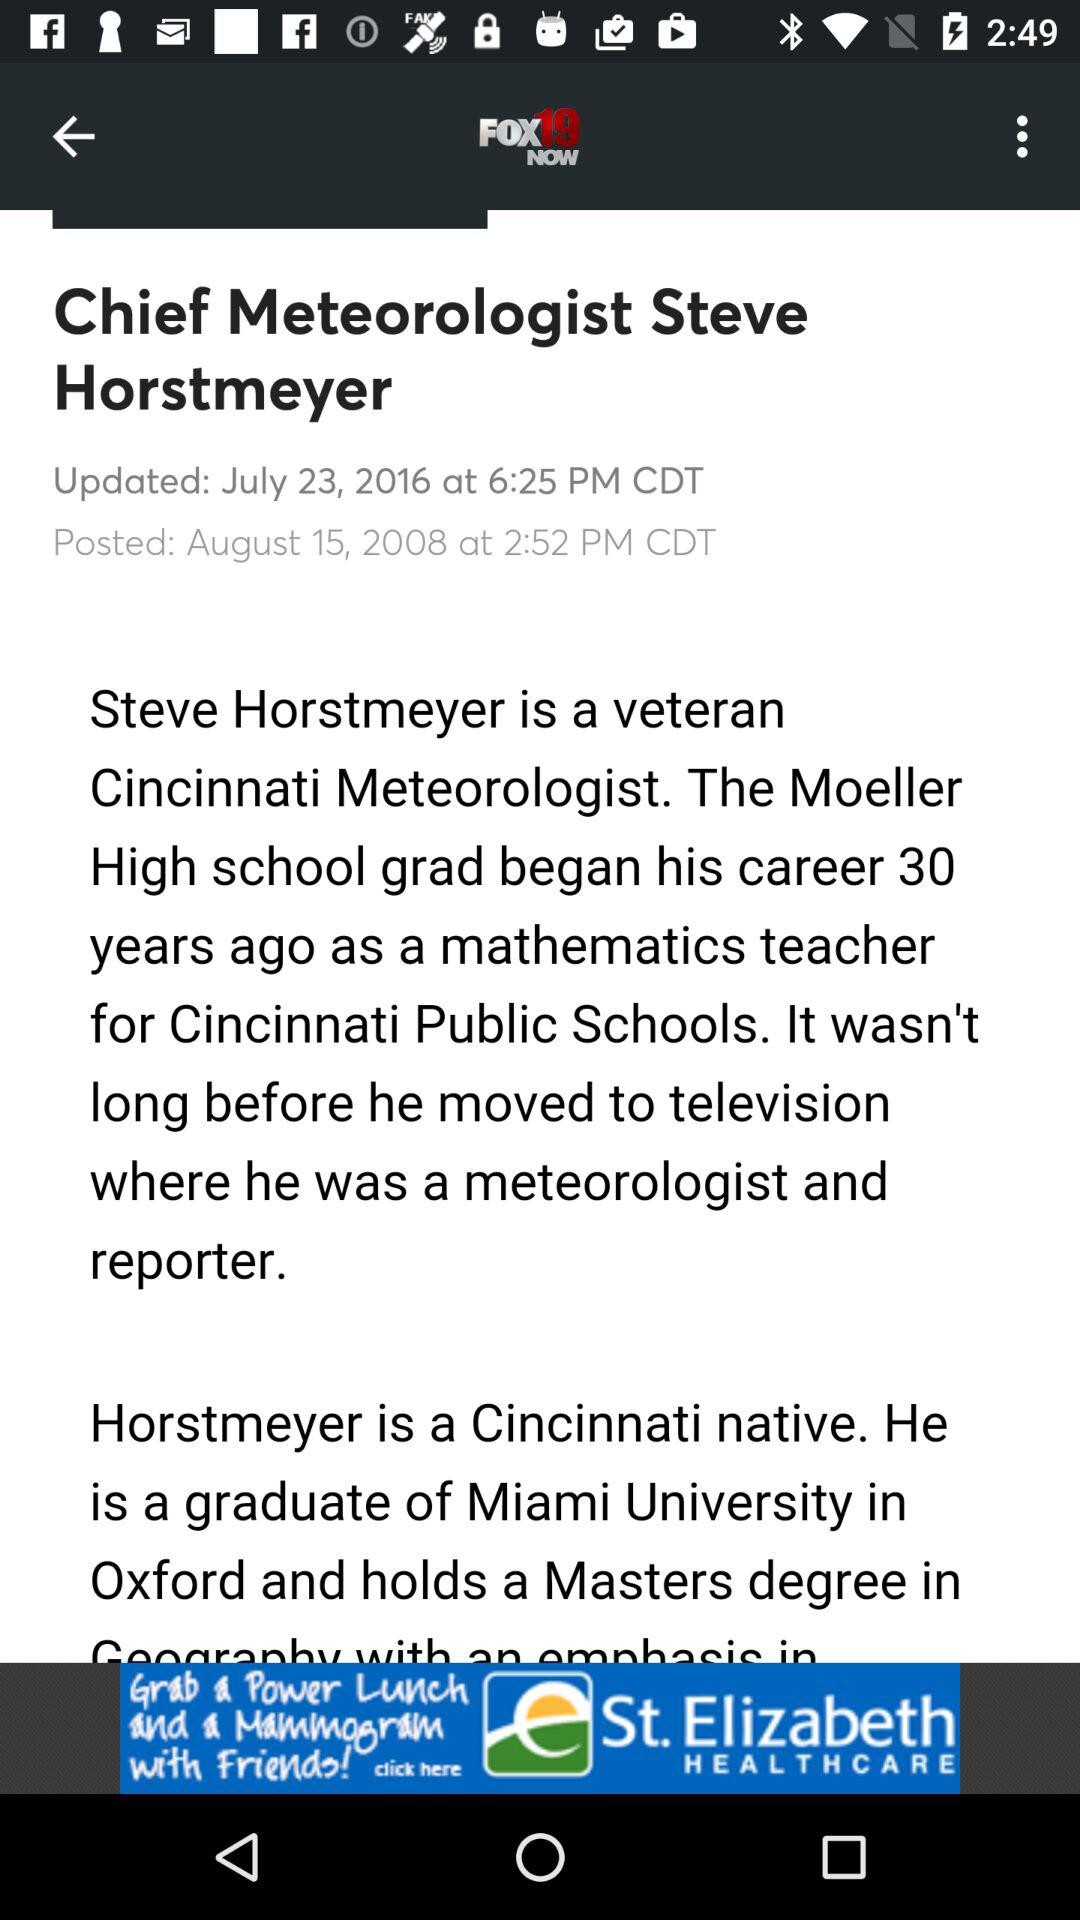How many years ago did the Moeller high school grad begin his career? The Moeller high school grad began his career 30 years ago. 